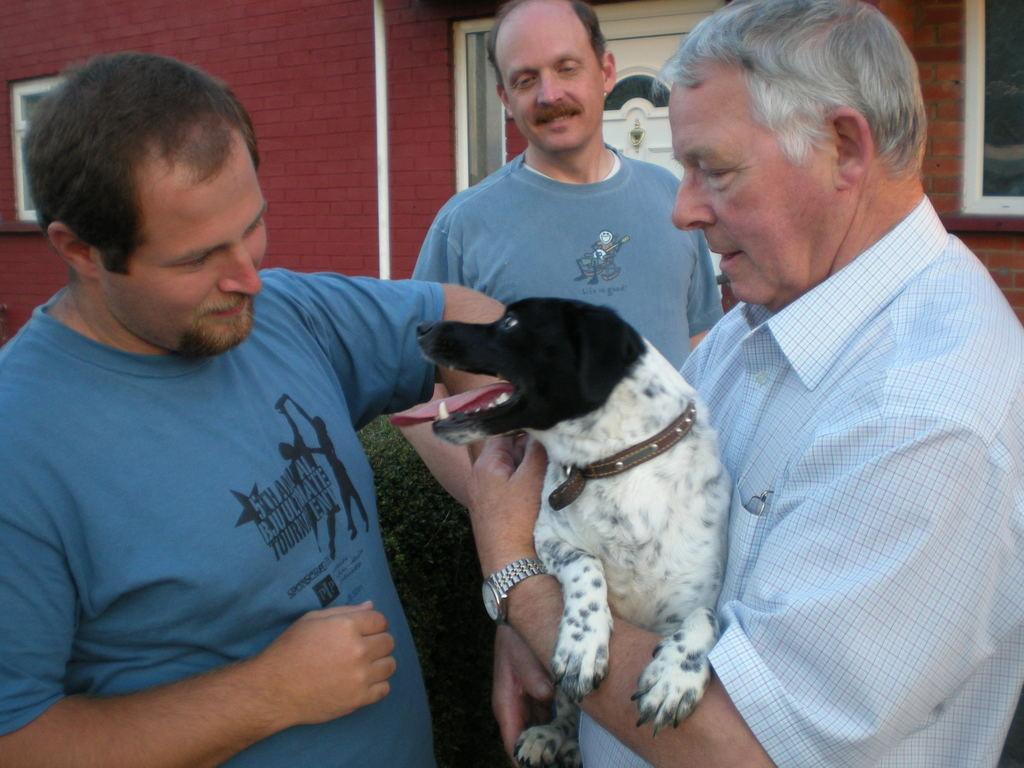In one or two sentences, can you explain what this image depicts? In this image, There are three persons standing and wearing colorful clothes. This person is wearing a watch and holding a dog with his hands. There is a building behind this person. 